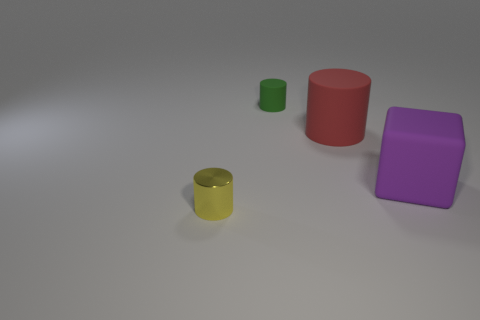Add 4 small green matte cylinders. How many objects exist? 8 Subtract all blocks. How many objects are left? 3 Subtract all rubber objects. Subtract all small yellow metallic blocks. How many objects are left? 1 Add 3 big matte blocks. How many big matte blocks are left? 4 Add 4 green rubber objects. How many green rubber objects exist? 5 Subtract 0 brown blocks. How many objects are left? 4 